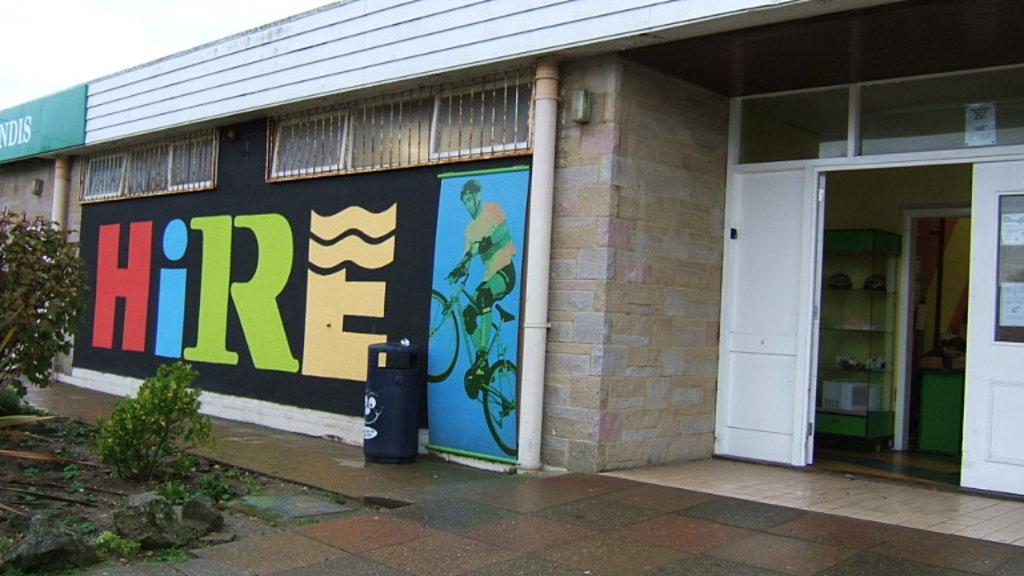How would you summarize this image in a sentence or two? In the center of the image we can see the sky, one building, wall, one board with some text, pipes, plants, grass, stones and a few other objects. And we can see the painting on the wall. 